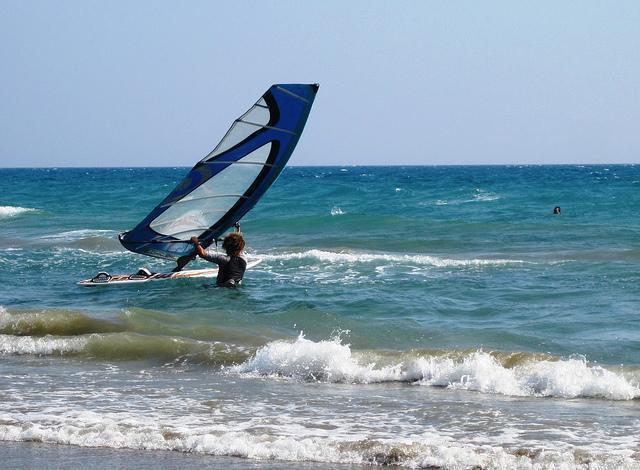What is he doing?
Pick the right solution, then justify: 'Answer: answer
Rationale: rationale.'
Options: Boarding board, sinking, taking board, falling. Answer: boarding board.
Rationale: The man is getting on his board. 